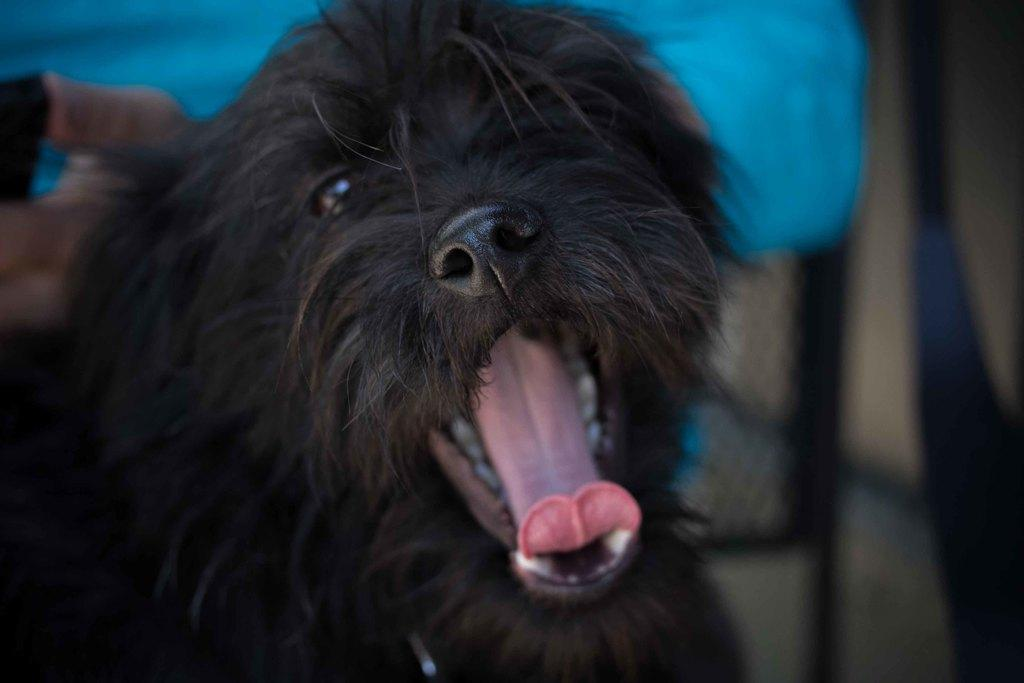What type of animal is in the image? There is a black dog in the image. Can you describe the background of the image? The background of the image is blurry. What type of whip is being used by the dog in the image? There is no whip present in the image, and the dog is not using any object. 